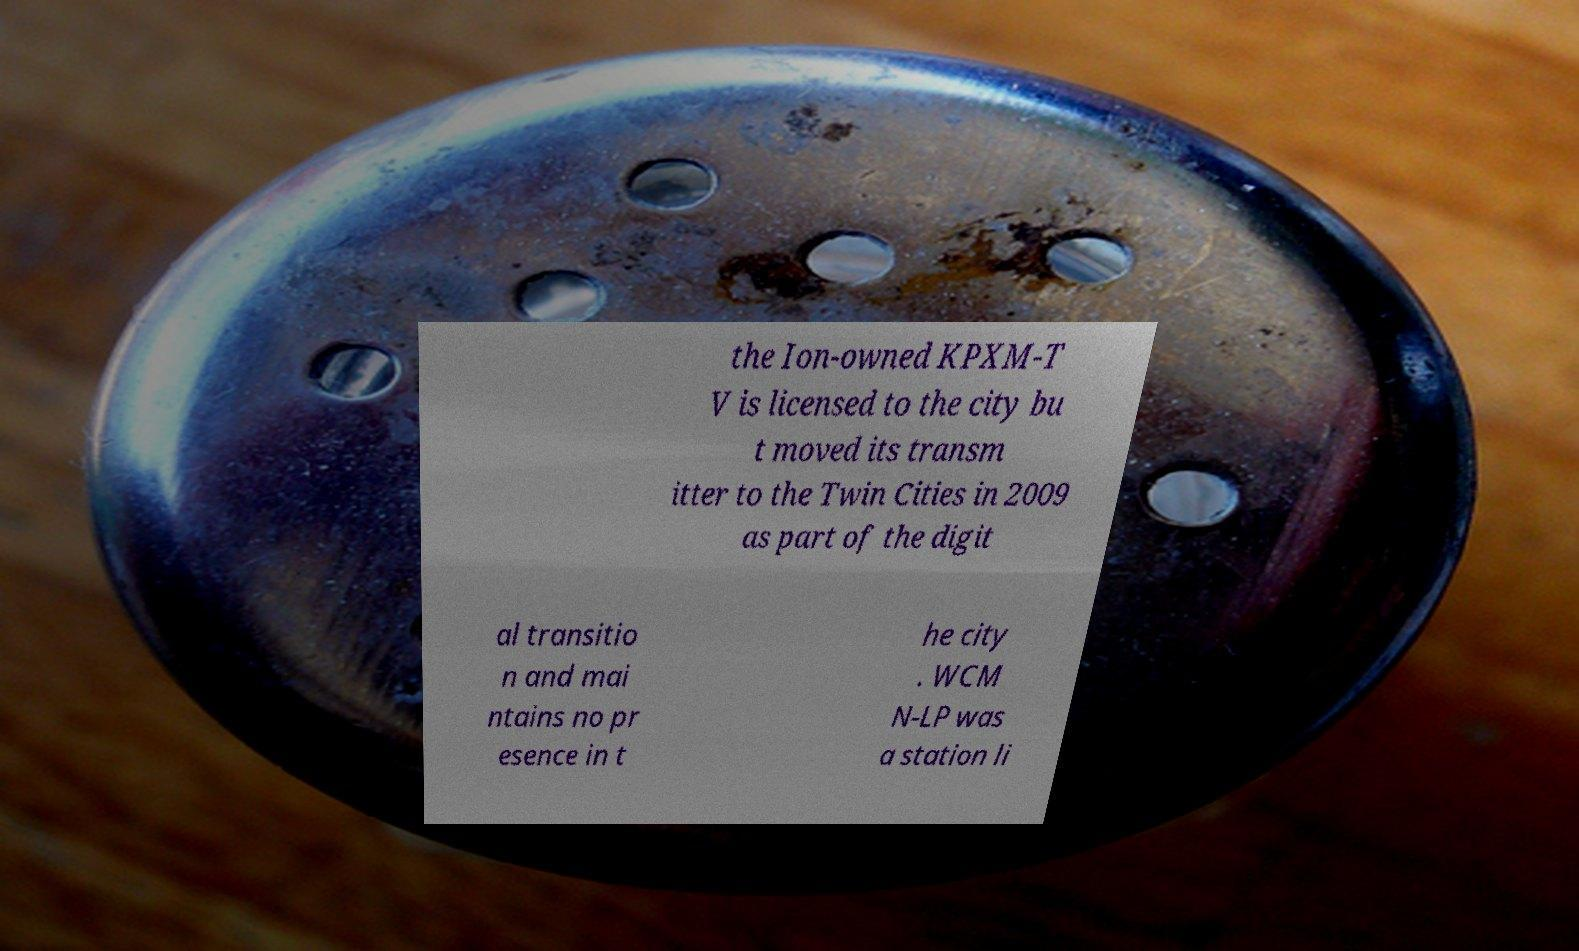Please read and relay the text visible in this image. What does it say? the Ion-owned KPXM-T V is licensed to the city bu t moved its transm itter to the Twin Cities in 2009 as part of the digit al transitio n and mai ntains no pr esence in t he city . WCM N-LP was a station li 